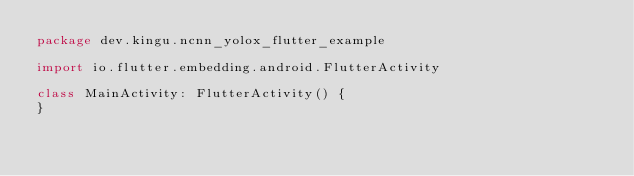Convert code to text. <code><loc_0><loc_0><loc_500><loc_500><_Kotlin_>package dev.kingu.ncnn_yolox_flutter_example

import io.flutter.embedding.android.FlutterActivity

class MainActivity: FlutterActivity() {
}
</code> 